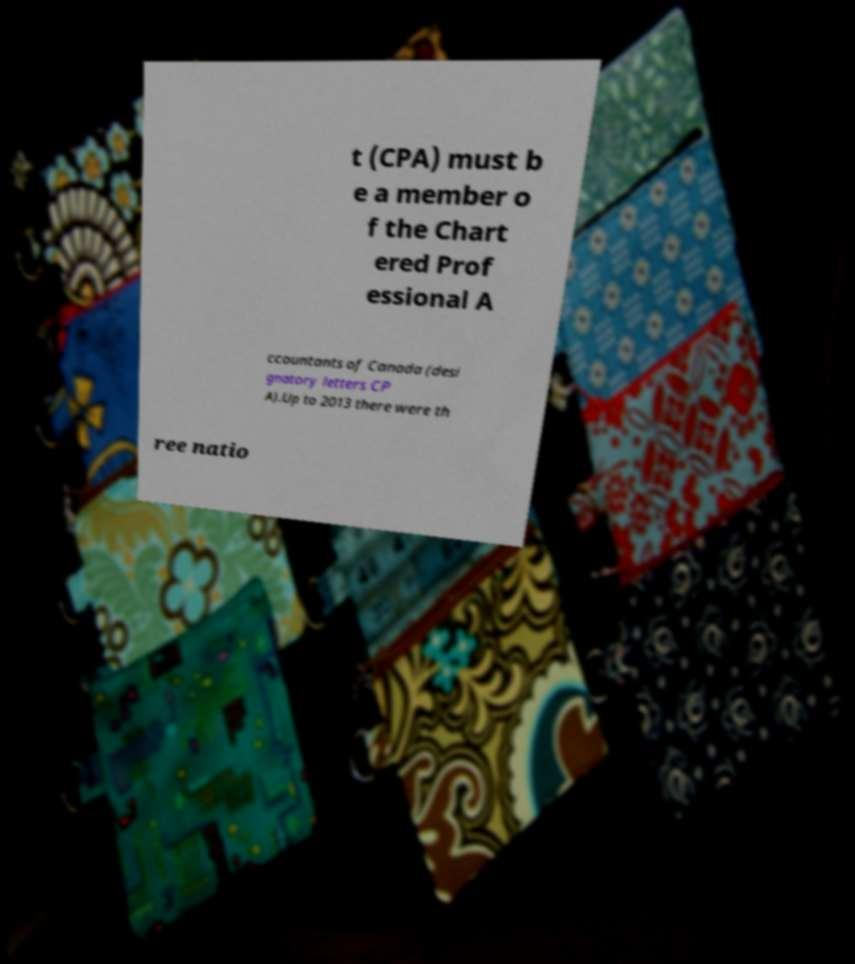Please identify and transcribe the text found in this image. t (CPA) must b e a member o f the Chart ered Prof essional A ccountants of Canada (desi gnatory letters CP A).Up to 2013 there were th ree natio 